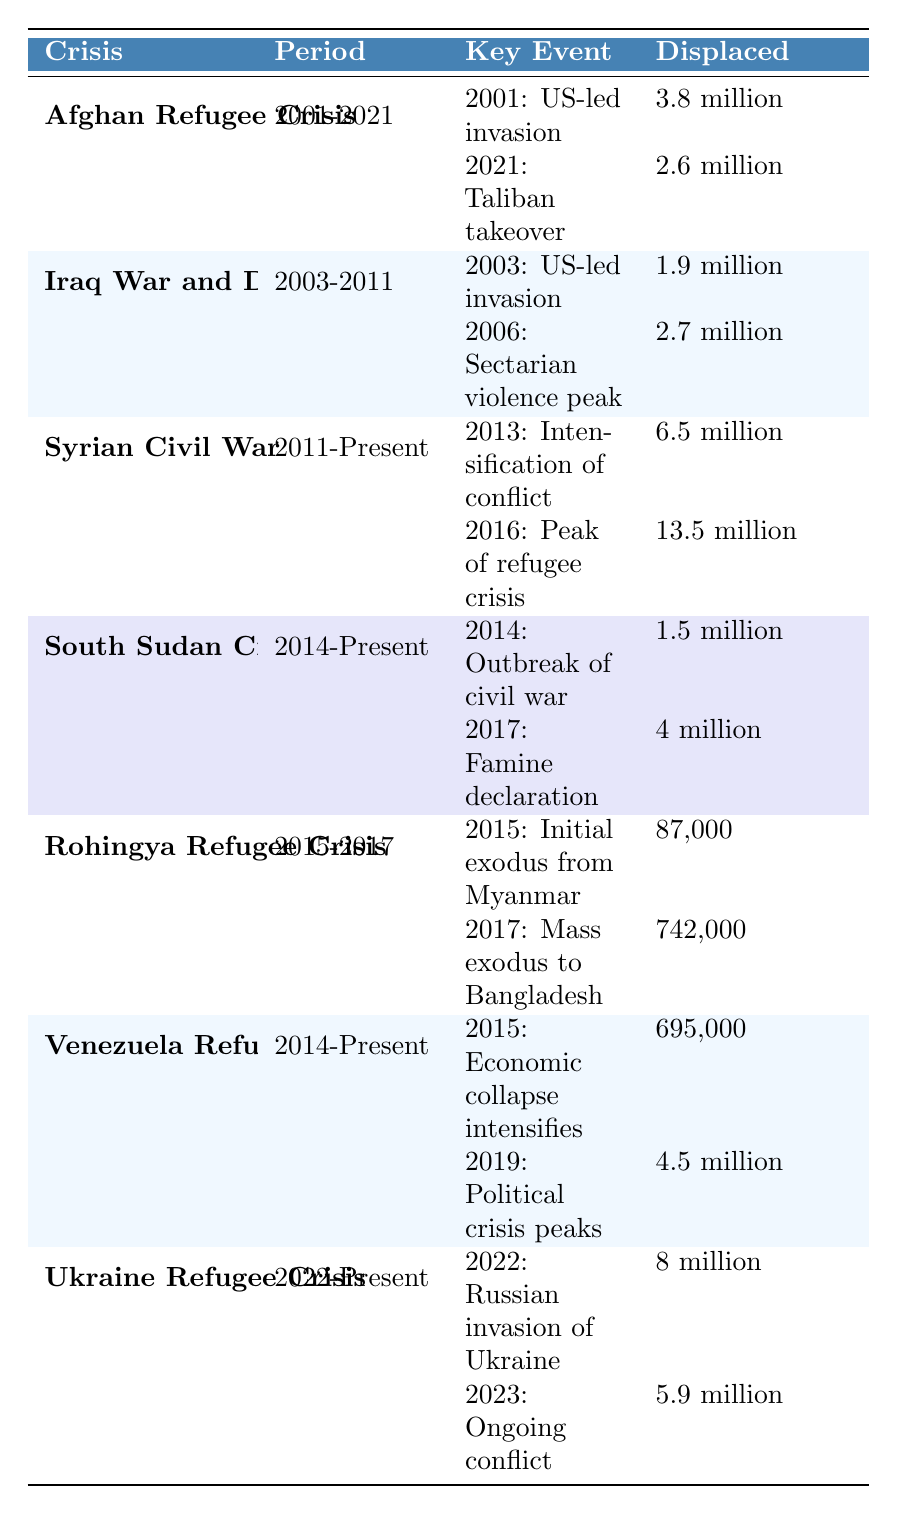What was the total number of people displaced by the Syrian Civil War up to 2016? According to the table, the displacement figures for the Syrian Civil War are 6.5 million in 2013 and 13.5 million in 2016. To find the total, we only need to consider the 2016 figure since it's the highest value provided.
Answer: 13.5 million How many people were displaced during the Rohingya Refugee Crisis in total? The Rohingya Refugee Crisis has two key events; in 2015, 87,000 were displaced, and in 2017, 742,000 were displaced. Adding these figures together gives 87,000 + 742,000 = 829,000.
Answer: 829,000 Was the initial exodus from Myanmar during the Rohingya Refugee Crisis higher or lower than the displacement caused by the outbreak of civil war in South Sudan in 2014? The initial exodus in the Rohingya Refugee Crisis was 87,000, while the displacement due to the civil war in South Sudan was 1.5 million. Comparing these figures, 87,000 is lower than 1.5 million.
Answer: Lower What was the change in the number of displaced people from the US-led invasion of Afghanistan in 2001 to the Taliban takeover in 2021? In 2001, 3.8 million were displaced due to the US-led invasion. By 2021, following the Taliban takeover, the number of displaced people reached 2.6 million. To assess the change, we calculate the difference: 3.8 million - 2.6 million = 1.2 million. Thus, there was a decrease of 1.2 million people displaced.
Answer: Decrease of 1.2 million Which displacement crisis resulted in the highest number of displaced individuals by 2023? Referring to the table, the crisis with the highest total number of displaced individuals by 2023 is the Syrian Civil War, with 13.5 million reported by 2016. Other crises do not exceed this number.
Answer: Syrian Civil War What is the total number of people displaced in the conflicts listed under the periods of 2014-Present? The total number for the periods of 2014-Present includes the South Sudan Civil War (1.5 million + 4 million), the Venezuela Refugee Crisis (695,000 + 4.5 million), and the ongoing Ukraine Refugee Crisis (8 million + 5.9 million). Summing these figures gives: (1.5 million + 4 million) + (695,000 + 4.5 million) + (8 million + 5.9 million) = 1.5 + 4 + 0.695 + 4.5 + 8 + 5.9 = 24.595 million.
Answer: 24.595 million How many refugees were displaced during the peak of the Syrian Civil War in 2016 compared to the total displaced from the Iraq War? The peak displacement during the Syrian Civil War in 2016 was 13.5 million, while total displacement during the Iraq War was 1.9 million (2003) + 2.7 million (2006) = 4.6 million. Comparing these, 13.5 million is significantly higher than 4.6 million.
Answer: 13.5 million is higher What is the median number of people displaced in the key events of the Ukrainian Refugee Crisis from 2022 to 2023? In the Ukrainian Refugee Crisis, there are two key events with 8 million in 2022 and 5.9 million in 2023. To find the median, we list the values: 5.9 million, 8 million. The median of two numbers is the average: (5.9 + 8) / 2 = 6.95 million.
Answer: 6.95 million Which refugee crisis had the smallest number of displaced individuals at one point in time, according to the table? The Rohingya Refugee Crisis recorded the smallest number at its initial exodus from Myanmar in 2015 with 87,000 displaced individuals. All other crises have higher displacement figures at comparable events.
Answer: Rohingya Refugee Crisis (87,000) 